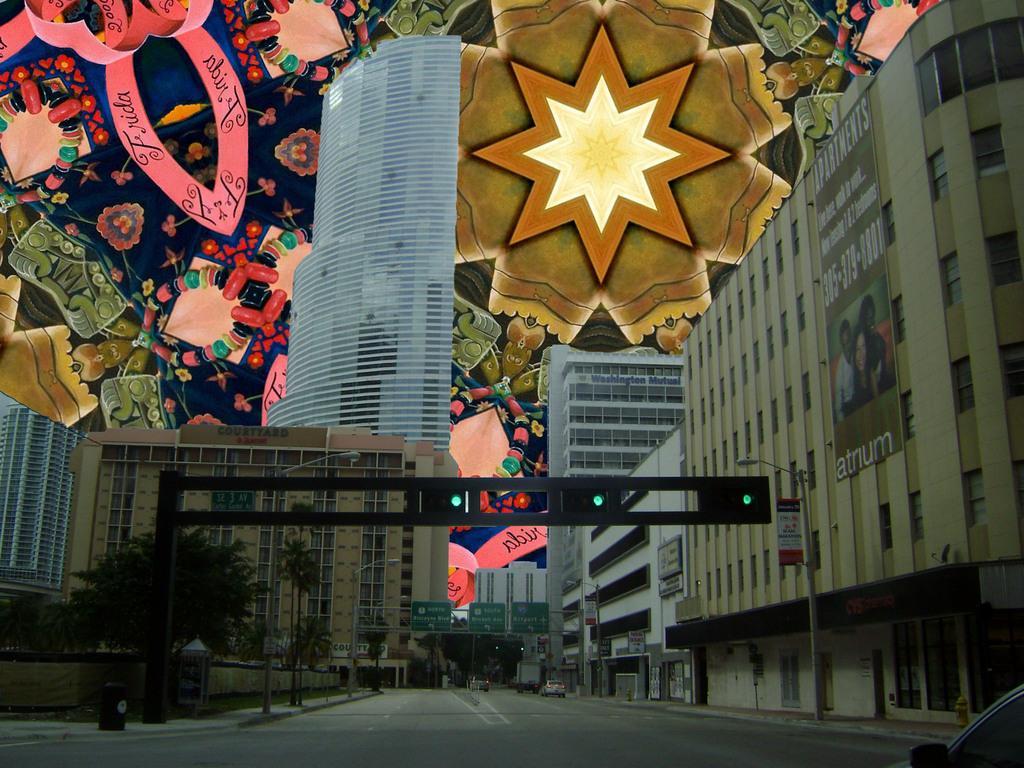In one or two sentences, can you explain what this image depicts? This image is taken outdoors. This image is an edited image. At the bottom of the image there is a road and there is a car. In the middle of the image there are a few buildings with walls, windows, doors and roofs. There is a skyscraper. There is a signal light. There are a few poles with street lights. There are a few trees. There are many boards with text on them. A few cars are moving on the road. At the top of the image it seems to be a tent with many colors. 